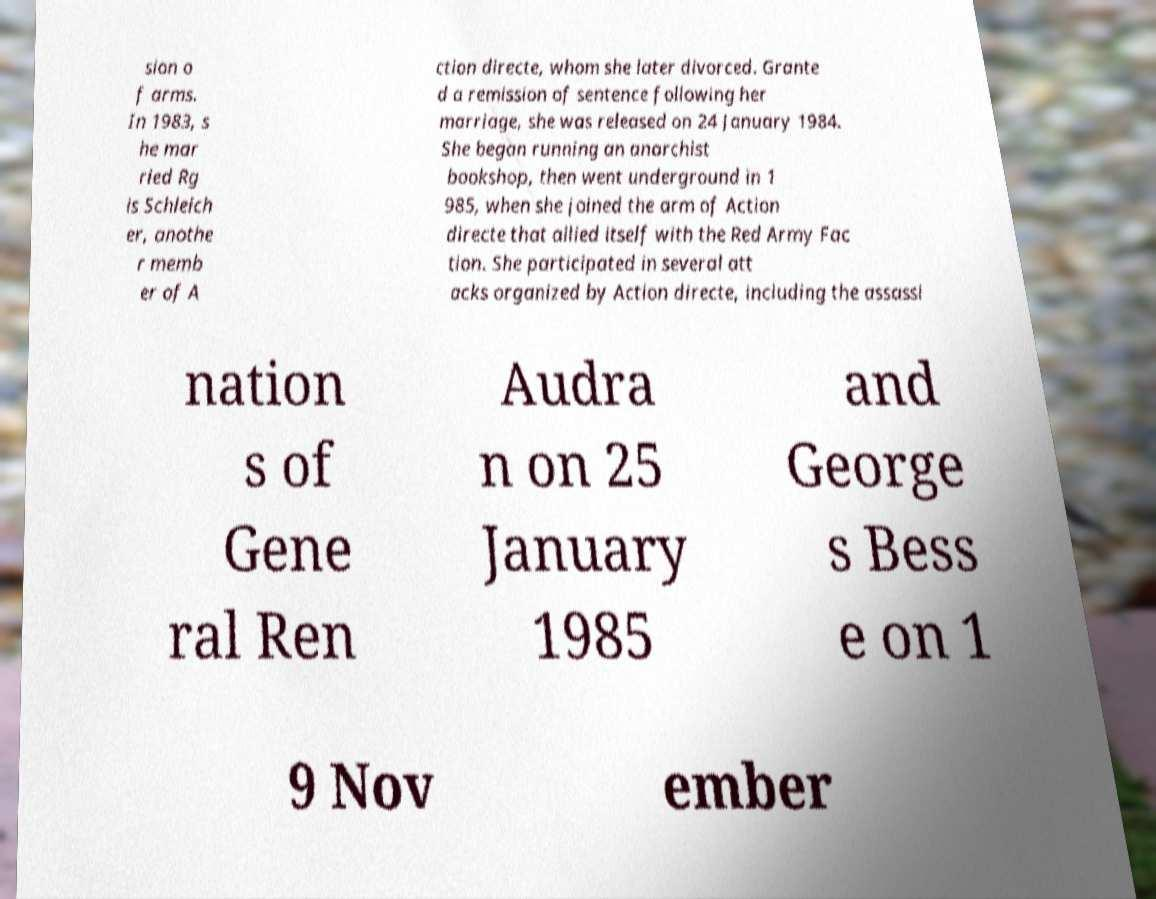Can you accurately transcribe the text from the provided image for me? sion o f arms. In 1983, s he mar ried Rg is Schleich er, anothe r memb er of A ction directe, whom she later divorced. Grante d a remission of sentence following her marriage, she was released on 24 January 1984. She began running an anarchist bookshop, then went underground in 1 985, when she joined the arm of Action directe that allied itself with the Red Army Fac tion. She participated in several att acks organized by Action directe, including the assassi nation s of Gene ral Ren Audra n on 25 January 1985 and George s Bess e on 1 9 Nov ember 